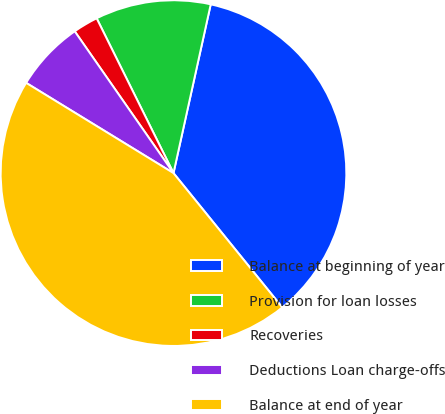Convert chart. <chart><loc_0><loc_0><loc_500><loc_500><pie_chart><fcel>Balance at beginning of year<fcel>Provision for loan losses<fcel>Recoveries<fcel>Deductions Loan charge-offs<fcel>Balance at end of year<nl><fcel>35.71%<fcel>10.79%<fcel>2.35%<fcel>6.57%<fcel>44.58%<nl></chart> 